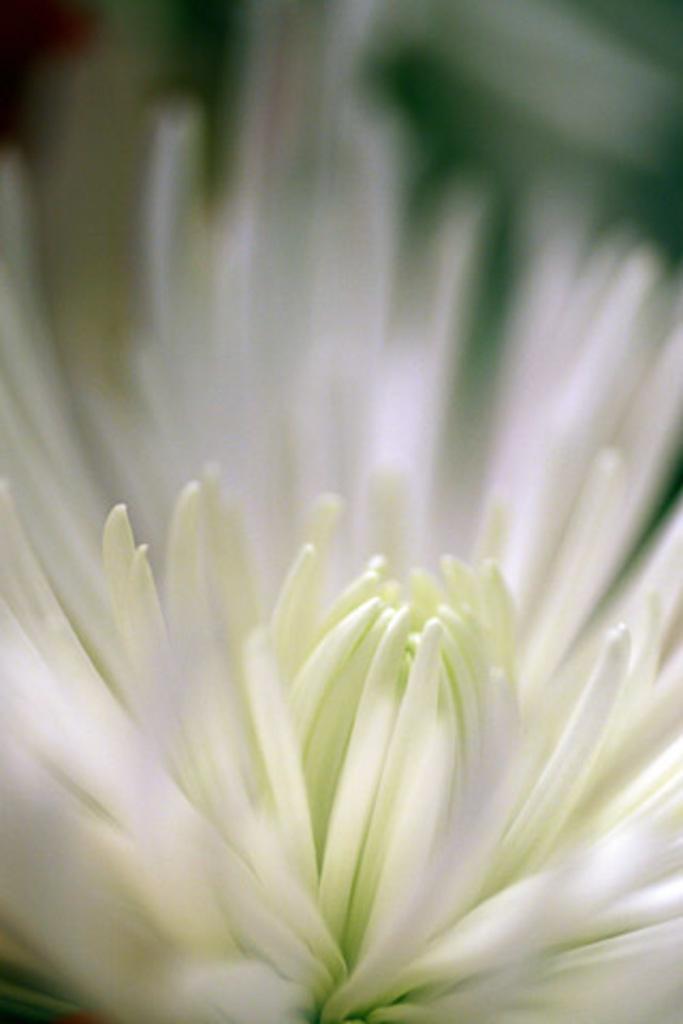Describe this image in one or two sentences. In this image, we can see a white flower. Background there is a blur view. 